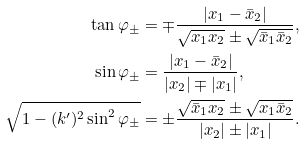Convert formula to latex. <formula><loc_0><loc_0><loc_500><loc_500>\tan \varphi _ { \pm } & = \mp \frac { | x _ { 1 } - \bar { x } _ { 2 } | } { \sqrt { x _ { 1 } x _ { 2 } } \pm \sqrt { \bar { x } _ { 1 } \bar { x } _ { 2 } } } , \\ \sin \varphi _ { \pm } & = \frac { | x _ { 1 } - \bar { x } _ { 2 } | } { | x _ { 2 } | \mp | x _ { 1 } | } , \\ \sqrt { 1 - ( k ^ { \prime } ) ^ { 2 } \sin ^ { 2 } \varphi _ { \pm } } & = \pm \frac { \sqrt { \bar { x } _ { 1 } x _ { 2 } } \pm \sqrt { x _ { 1 } \bar { x } _ { 2 } } } { | x _ { 2 } | \pm | x _ { 1 } | } .</formula> 